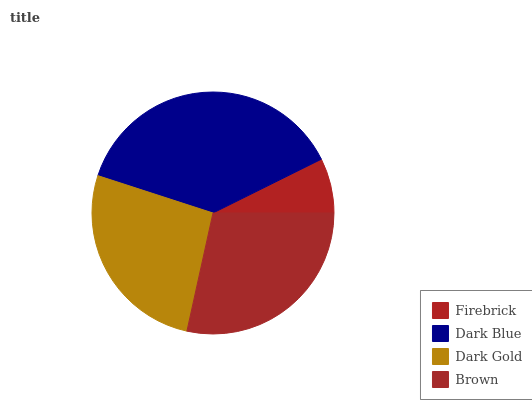Is Firebrick the minimum?
Answer yes or no. Yes. Is Dark Blue the maximum?
Answer yes or no. Yes. Is Dark Gold the minimum?
Answer yes or no. No. Is Dark Gold the maximum?
Answer yes or no. No. Is Dark Blue greater than Dark Gold?
Answer yes or no. Yes. Is Dark Gold less than Dark Blue?
Answer yes or no. Yes. Is Dark Gold greater than Dark Blue?
Answer yes or no. No. Is Dark Blue less than Dark Gold?
Answer yes or no. No. Is Brown the high median?
Answer yes or no. Yes. Is Dark Gold the low median?
Answer yes or no. Yes. Is Dark Blue the high median?
Answer yes or no. No. Is Dark Blue the low median?
Answer yes or no. No. 